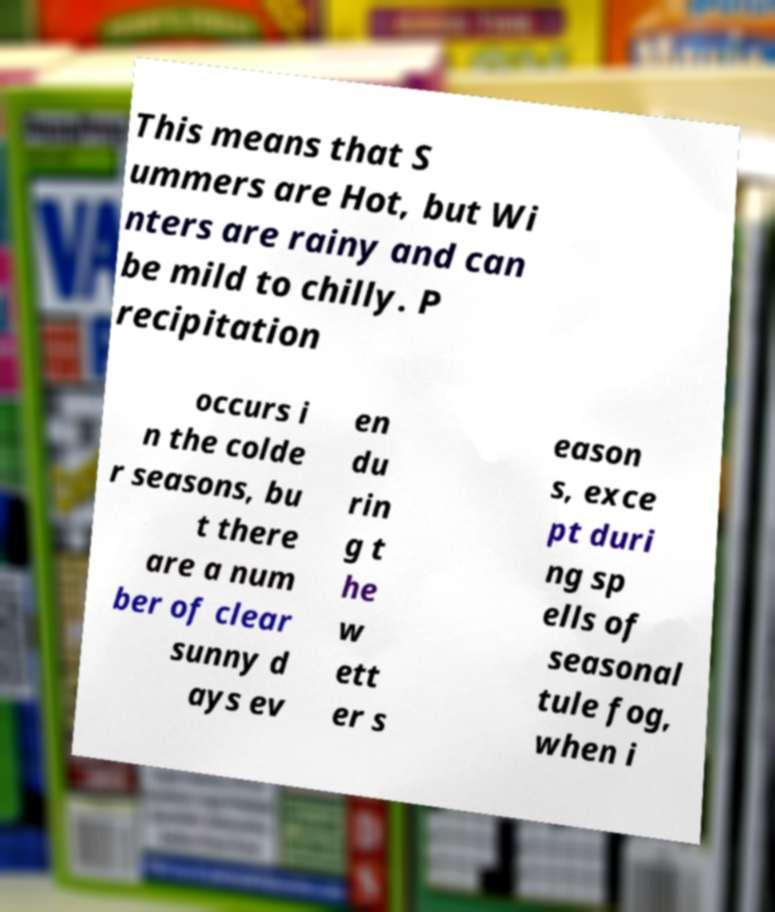I need the written content from this picture converted into text. Can you do that? This means that S ummers are Hot, but Wi nters are rainy and can be mild to chilly. P recipitation occurs i n the colde r seasons, bu t there are a num ber of clear sunny d ays ev en du rin g t he w ett er s eason s, exce pt duri ng sp ells of seasonal tule fog, when i 